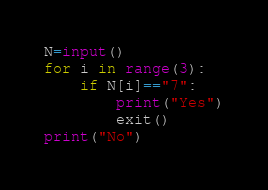Convert code to text. <code><loc_0><loc_0><loc_500><loc_500><_Python_>N=input()
for i in range(3):
    if N[i]=="7":
        print("Yes")
        exit()
print("No")</code> 